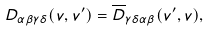<formula> <loc_0><loc_0><loc_500><loc_500>D _ { \alpha \beta \gamma \delta } ( v , v ^ { \prime } ) = \overline { D } _ { \gamma \delta \alpha \beta } ( v ^ { \prime } , v ) ,</formula> 